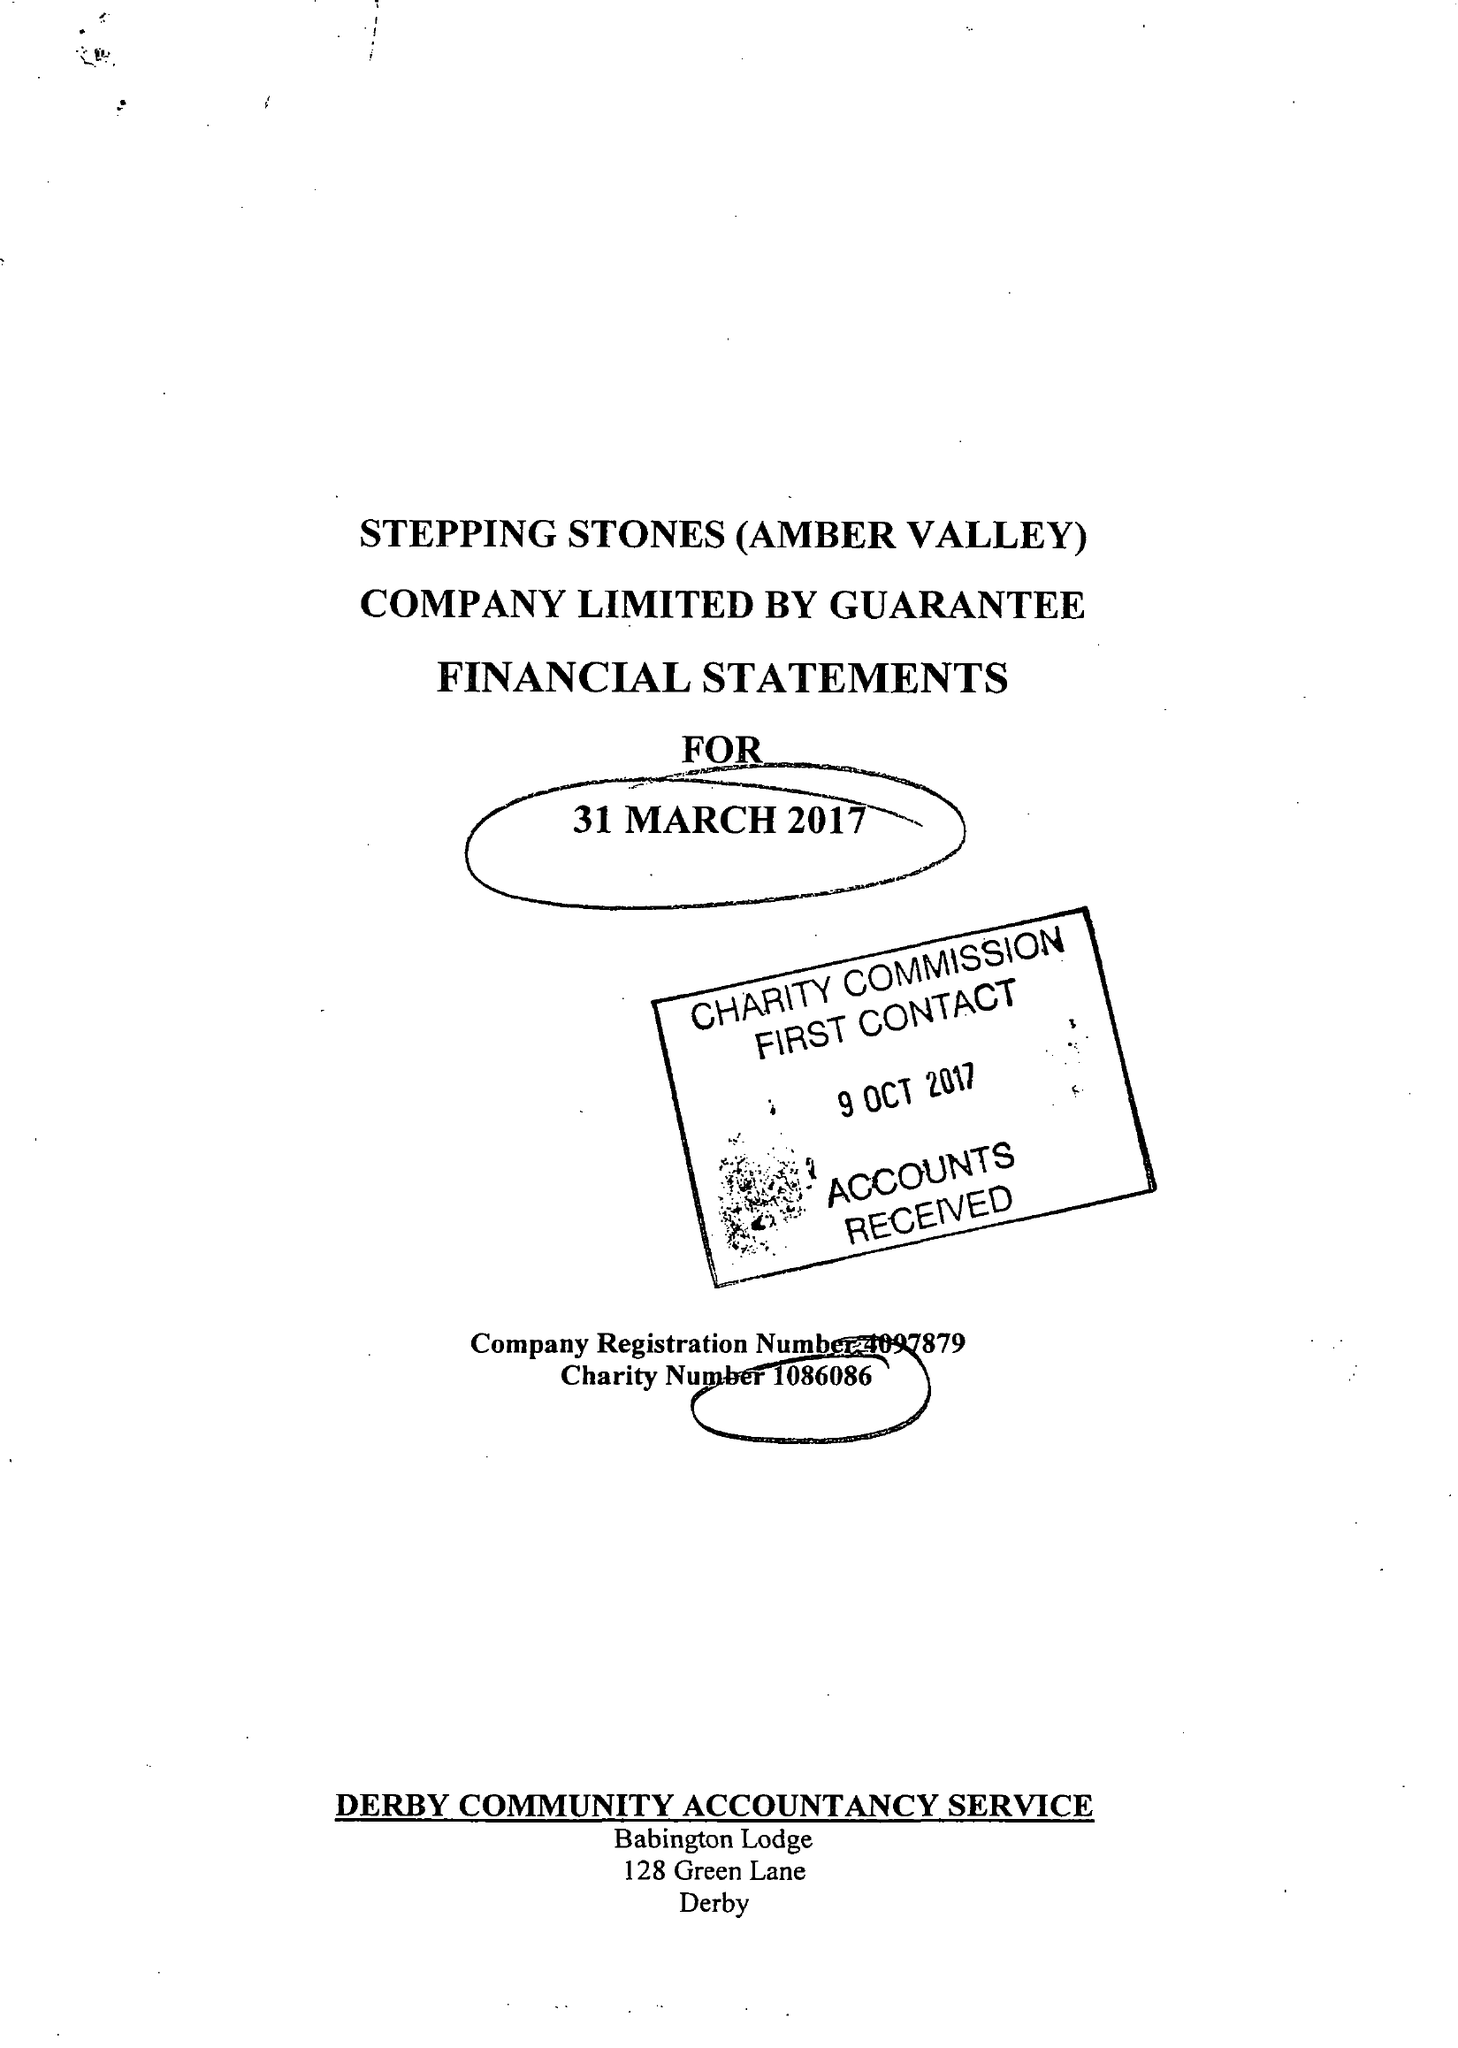What is the value for the report_date?
Answer the question using a single word or phrase. 2017-03-31 